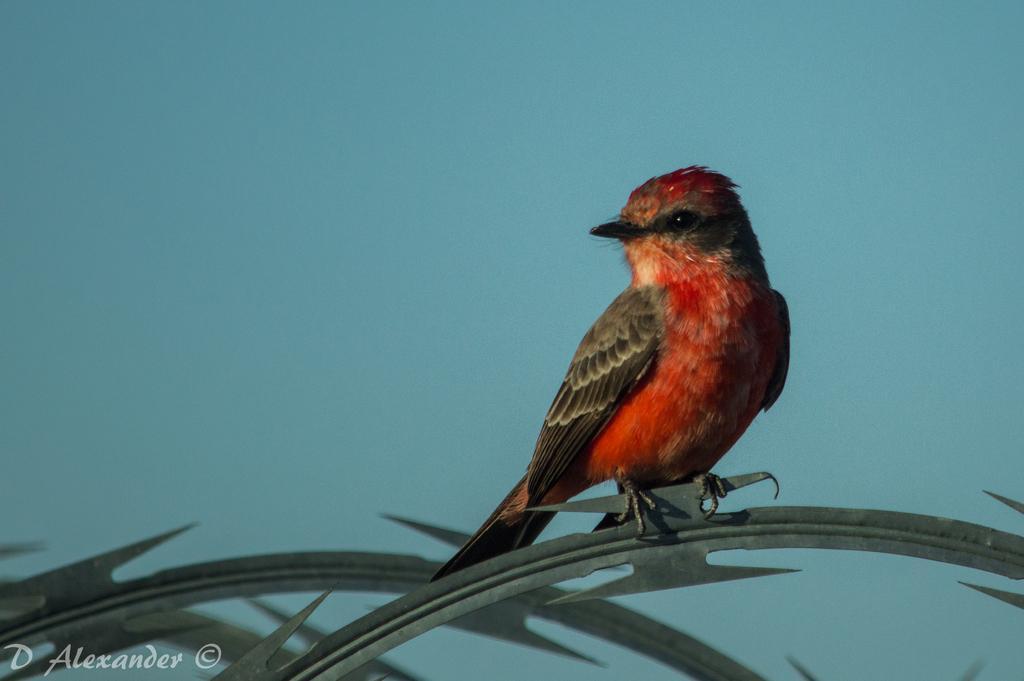What type of animal can be seen in the image? There is a bird in the image. Where is the bird located? The bird is on a leaf. Is there any text present in the image? Yes, there is text in the bottom left corner of the image. What type of mine is depicted in the image? There is no mine present in the image; it features a bird on a leaf and text in the bottom left corner. What kind of steel is used to create the bird in the image? The bird in the image is not made of steel; it is a living creature. 